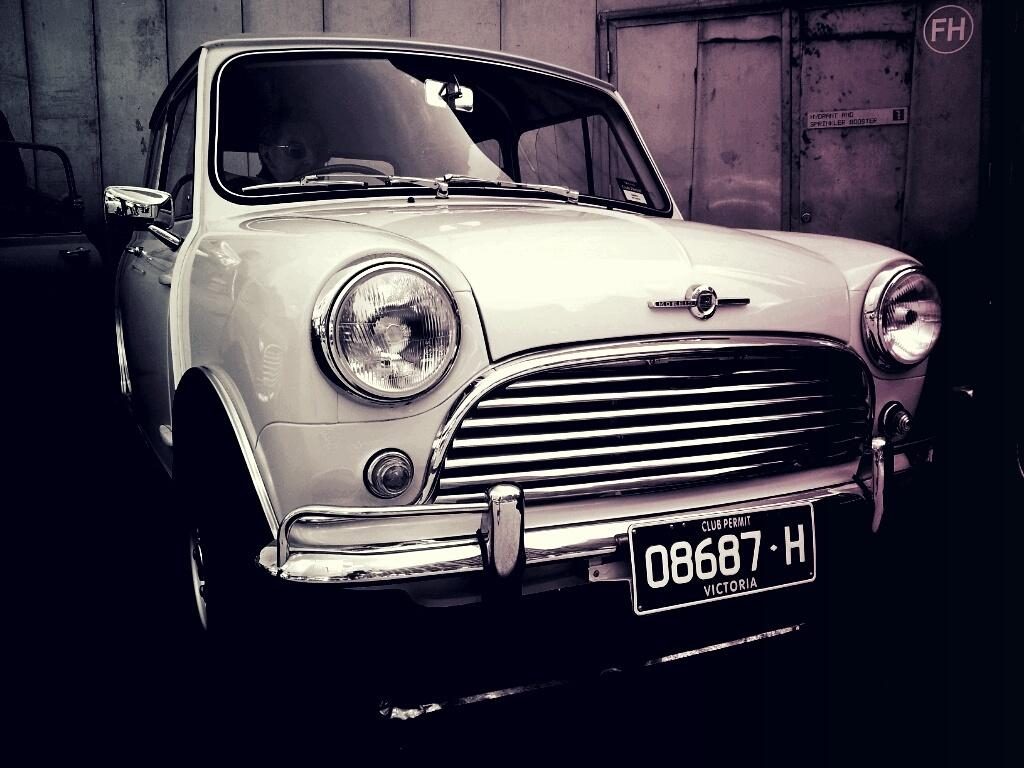<image>
Summarize the visual content of the image. an old car in a garage has license plate 08687-H 